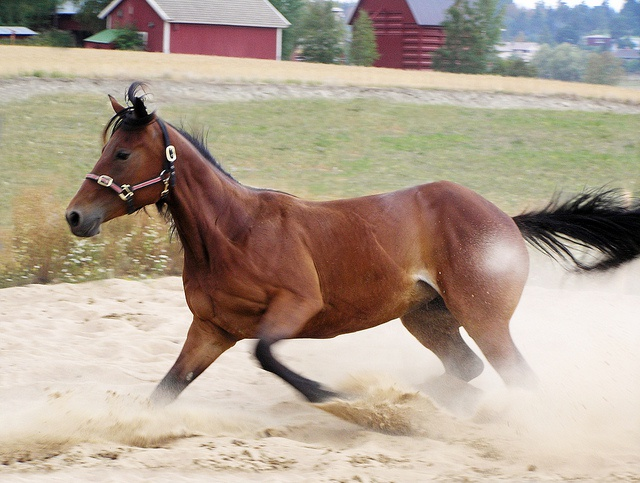Describe the objects in this image and their specific colors. I can see a horse in black, maroon, and brown tones in this image. 